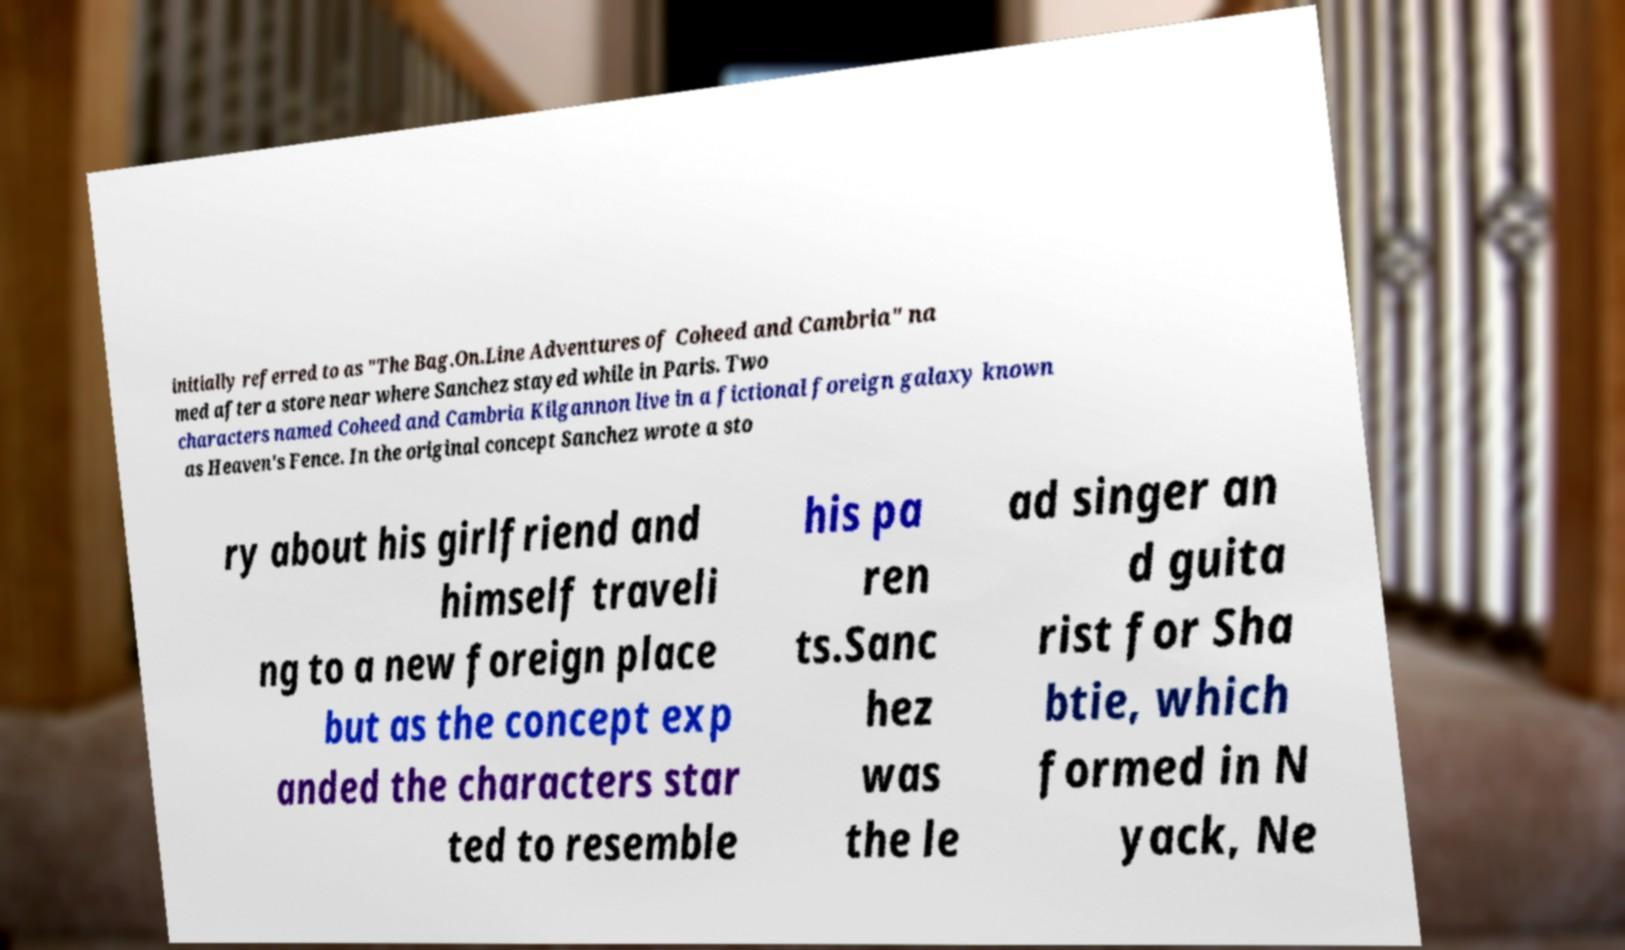Can you accurately transcribe the text from the provided image for me? initially referred to as "The Bag.On.Line Adventures of Coheed and Cambria" na med after a store near where Sanchez stayed while in Paris. Two characters named Coheed and Cambria Kilgannon live in a fictional foreign galaxy known as Heaven's Fence. In the original concept Sanchez wrote a sto ry about his girlfriend and himself traveli ng to a new foreign place but as the concept exp anded the characters star ted to resemble his pa ren ts.Sanc hez was the le ad singer an d guita rist for Sha btie, which formed in N yack, Ne 